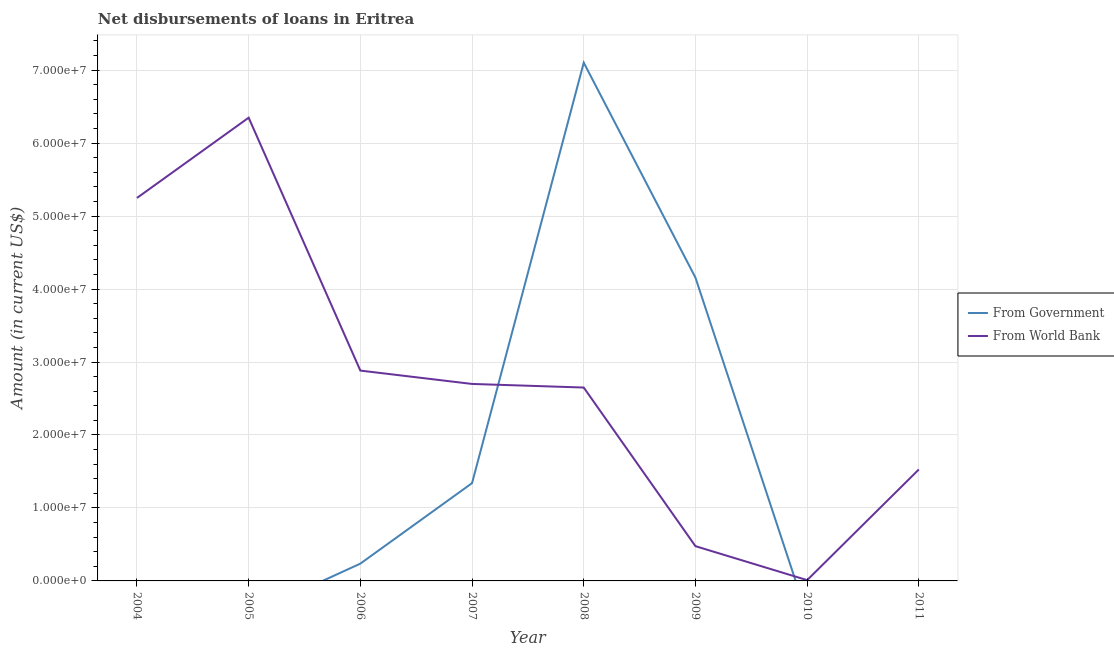Does the line corresponding to net disbursements of loan from government intersect with the line corresponding to net disbursements of loan from world bank?
Provide a short and direct response. Yes. Is the number of lines equal to the number of legend labels?
Provide a short and direct response. No. What is the net disbursements of loan from government in 2009?
Give a very brief answer. 4.16e+07. Across all years, what is the maximum net disbursements of loan from world bank?
Keep it short and to the point. 6.35e+07. Across all years, what is the minimum net disbursements of loan from world bank?
Give a very brief answer. 1.08e+05. In which year was the net disbursements of loan from world bank maximum?
Offer a terse response. 2005. What is the total net disbursements of loan from world bank in the graph?
Give a very brief answer. 2.18e+08. What is the difference between the net disbursements of loan from world bank in 2004 and that in 2005?
Keep it short and to the point. -1.10e+07. What is the difference between the net disbursements of loan from government in 2011 and the net disbursements of loan from world bank in 2005?
Offer a very short reply. -6.35e+07. What is the average net disbursements of loan from government per year?
Provide a succinct answer. 1.60e+07. In the year 2008, what is the difference between the net disbursements of loan from world bank and net disbursements of loan from government?
Offer a terse response. -4.45e+07. What is the ratio of the net disbursements of loan from world bank in 2005 to that in 2007?
Give a very brief answer. 2.35. Is the net disbursements of loan from government in 2006 less than that in 2009?
Ensure brevity in your answer.  Yes. What is the difference between the highest and the second highest net disbursements of loan from world bank?
Keep it short and to the point. 1.10e+07. What is the difference between the highest and the lowest net disbursements of loan from government?
Your answer should be very brief. 7.10e+07. Is the sum of the net disbursements of loan from world bank in 2005 and 2010 greater than the maximum net disbursements of loan from government across all years?
Make the answer very short. No. Does the net disbursements of loan from government monotonically increase over the years?
Provide a succinct answer. No. Is the net disbursements of loan from government strictly greater than the net disbursements of loan from world bank over the years?
Make the answer very short. No. Is the net disbursements of loan from government strictly less than the net disbursements of loan from world bank over the years?
Ensure brevity in your answer.  No. How many years are there in the graph?
Make the answer very short. 8. Are the values on the major ticks of Y-axis written in scientific E-notation?
Offer a terse response. Yes. Does the graph contain grids?
Make the answer very short. Yes. How are the legend labels stacked?
Offer a terse response. Vertical. What is the title of the graph?
Provide a succinct answer. Net disbursements of loans in Eritrea. What is the Amount (in current US$) of From Government in 2004?
Give a very brief answer. 0. What is the Amount (in current US$) of From World Bank in 2004?
Keep it short and to the point. 5.25e+07. What is the Amount (in current US$) of From World Bank in 2005?
Offer a very short reply. 6.35e+07. What is the Amount (in current US$) in From Government in 2006?
Ensure brevity in your answer.  2.37e+06. What is the Amount (in current US$) of From World Bank in 2006?
Provide a succinct answer. 2.88e+07. What is the Amount (in current US$) in From Government in 2007?
Keep it short and to the point. 1.34e+07. What is the Amount (in current US$) of From World Bank in 2007?
Your answer should be compact. 2.70e+07. What is the Amount (in current US$) of From Government in 2008?
Make the answer very short. 7.10e+07. What is the Amount (in current US$) in From World Bank in 2008?
Ensure brevity in your answer.  2.65e+07. What is the Amount (in current US$) of From Government in 2009?
Your response must be concise. 4.16e+07. What is the Amount (in current US$) in From World Bank in 2009?
Your answer should be compact. 4.76e+06. What is the Amount (in current US$) in From World Bank in 2010?
Your answer should be very brief. 1.08e+05. What is the Amount (in current US$) of From World Bank in 2011?
Give a very brief answer. 1.53e+07. Across all years, what is the maximum Amount (in current US$) of From Government?
Provide a short and direct response. 7.10e+07. Across all years, what is the maximum Amount (in current US$) in From World Bank?
Provide a short and direct response. 6.35e+07. Across all years, what is the minimum Amount (in current US$) of From Government?
Provide a short and direct response. 0. Across all years, what is the minimum Amount (in current US$) of From World Bank?
Keep it short and to the point. 1.08e+05. What is the total Amount (in current US$) in From Government in the graph?
Offer a terse response. 1.28e+08. What is the total Amount (in current US$) of From World Bank in the graph?
Offer a very short reply. 2.18e+08. What is the difference between the Amount (in current US$) of From World Bank in 2004 and that in 2005?
Offer a very short reply. -1.10e+07. What is the difference between the Amount (in current US$) of From World Bank in 2004 and that in 2006?
Offer a terse response. 2.37e+07. What is the difference between the Amount (in current US$) of From World Bank in 2004 and that in 2007?
Provide a succinct answer. 2.55e+07. What is the difference between the Amount (in current US$) of From World Bank in 2004 and that in 2008?
Offer a terse response. 2.60e+07. What is the difference between the Amount (in current US$) of From World Bank in 2004 and that in 2009?
Keep it short and to the point. 4.77e+07. What is the difference between the Amount (in current US$) of From World Bank in 2004 and that in 2010?
Your response must be concise. 5.24e+07. What is the difference between the Amount (in current US$) in From World Bank in 2004 and that in 2011?
Offer a terse response. 3.72e+07. What is the difference between the Amount (in current US$) in From World Bank in 2005 and that in 2006?
Your answer should be compact. 3.47e+07. What is the difference between the Amount (in current US$) in From World Bank in 2005 and that in 2007?
Your answer should be very brief. 3.65e+07. What is the difference between the Amount (in current US$) in From World Bank in 2005 and that in 2008?
Give a very brief answer. 3.70e+07. What is the difference between the Amount (in current US$) of From World Bank in 2005 and that in 2009?
Ensure brevity in your answer.  5.87e+07. What is the difference between the Amount (in current US$) of From World Bank in 2005 and that in 2010?
Your answer should be compact. 6.34e+07. What is the difference between the Amount (in current US$) in From World Bank in 2005 and that in 2011?
Provide a short and direct response. 4.82e+07. What is the difference between the Amount (in current US$) in From Government in 2006 and that in 2007?
Offer a terse response. -1.10e+07. What is the difference between the Amount (in current US$) in From World Bank in 2006 and that in 2007?
Make the answer very short. 1.83e+06. What is the difference between the Amount (in current US$) in From Government in 2006 and that in 2008?
Offer a very short reply. -6.87e+07. What is the difference between the Amount (in current US$) of From World Bank in 2006 and that in 2008?
Ensure brevity in your answer.  2.32e+06. What is the difference between the Amount (in current US$) in From Government in 2006 and that in 2009?
Offer a terse response. -3.92e+07. What is the difference between the Amount (in current US$) of From World Bank in 2006 and that in 2009?
Give a very brief answer. 2.41e+07. What is the difference between the Amount (in current US$) in From World Bank in 2006 and that in 2010?
Offer a very short reply. 2.87e+07. What is the difference between the Amount (in current US$) in From World Bank in 2006 and that in 2011?
Provide a succinct answer. 1.35e+07. What is the difference between the Amount (in current US$) in From Government in 2007 and that in 2008?
Give a very brief answer. -5.76e+07. What is the difference between the Amount (in current US$) of From World Bank in 2007 and that in 2008?
Make the answer very short. 4.93e+05. What is the difference between the Amount (in current US$) in From Government in 2007 and that in 2009?
Your response must be concise. -2.82e+07. What is the difference between the Amount (in current US$) in From World Bank in 2007 and that in 2009?
Provide a succinct answer. 2.22e+07. What is the difference between the Amount (in current US$) in From World Bank in 2007 and that in 2010?
Your answer should be very brief. 2.69e+07. What is the difference between the Amount (in current US$) in From World Bank in 2007 and that in 2011?
Make the answer very short. 1.17e+07. What is the difference between the Amount (in current US$) of From Government in 2008 and that in 2009?
Provide a short and direct response. 2.95e+07. What is the difference between the Amount (in current US$) of From World Bank in 2008 and that in 2009?
Provide a short and direct response. 2.17e+07. What is the difference between the Amount (in current US$) of From World Bank in 2008 and that in 2010?
Make the answer very short. 2.64e+07. What is the difference between the Amount (in current US$) of From World Bank in 2008 and that in 2011?
Ensure brevity in your answer.  1.12e+07. What is the difference between the Amount (in current US$) in From World Bank in 2009 and that in 2010?
Offer a terse response. 4.66e+06. What is the difference between the Amount (in current US$) in From World Bank in 2009 and that in 2011?
Provide a succinct answer. -1.05e+07. What is the difference between the Amount (in current US$) of From World Bank in 2010 and that in 2011?
Offer a terse response. -1.52e+07. What is the difference between the Amount (in current US$) in From Government in 2006 and the Amount (in current US$) in From World Bank in 2007?
Ensure brevity in your answer.  -2.46e+07. What is the difference between the Amount (in current US$) in From Government in 2006 and the Amount (in current US$) in From World Bank in 2008?
Provide a short and direct response. -2.41e+07. What is the difference between the Amount (in current US$) in From Government in 2006 and the Amount (in current US$) in From World Bank in 2009?
Give a very brief answer. -2.39e+06. What is the difference between the Amount (in current US$) in From Government in 2006 and the Amount (in current US$) in From World Bank in 2010?
Ensure brevity in your answer.  2.26e+06. What is the difference between the Amount (in current US$) in From Government in 2006 and the Amount (in current US$) in From World Bank in 2011?
Ensure brevity in your answer.  -1.29e+07. What is the difference between the Amount (in current US$) of From Government in 2007 and the Amount (in current US$) of From World Bank in 2008?
Make the answer very short. -1.31e+07. What is the difference between the Amount (in current US$) in From Government in 2007 and the Amount (in current US$) in From World Bank in 2009?
Make the answer very short. 8.64e+06. What is the difference between the Amount (in current US$) of From Government in 2007 and the Amount (in current US$) of From World Bank in 2010?
Make the answer very short. 1.33e+07. What is the difference between the Amount (in current US$) in From Government in 2007 and the Amount (in current US$) in From World Bank in 2011?
Your response must be concise. -1.88e+06. What is the difference between the Amount (in current US$) of From Government in 2008 and the Amount (in current US$) of From World Bank in 2009?
Give a very brief answer. 6.63e+07. What is the difference between the Amount (in current US$) of From Government in 2008 and the Amount (in current US$) of From World Bank in 2010?
Your answer should be very brief. 7.09e+07. What is the difference between the Amount (in current US$) in From Government in 2008 and the Amount (in current US$) in From World Bank in 2011?
Provide a short and direct response. 5.58e+07. What is the difference between the Amount (in current US$) in From Government in 2009 and the Amount (in current US$) in From World Bank in 2010?
Keep it short and to the point. 4.15e+07. What is the difference between the Amount (in current US$) in From Government in 2009 and the Amount (in current US$) in From World Bank in 2011?
Make the answer very short. 2.63e+07. What is the average Amount (in current US$) in From Government per year?
Your answer should be very brief. 1.60e+07. What is the average Amount (in current US$) in From World Bank per year?
Your answer should be very brief. 2.73e+07. In the year 2006, what is the difference between the Amount (in current US$) of From Government and Amount (in current US$) of From World Bank?
Your response must be concise. -2.65e+07. In the year 2007, what is the difference between the Amount (in current US$) in From Government and Amount (in current US$) in From World Bank?
Provide a short and direct response. -1.36e+07. In the year 2008, what is the difference between the Amount (in current US$) in From Government and Amount (in current US$) in From World Bank?
Provide a short and direct response. 4.45e+07. In the year 2009, what is the difference between the Amount (in current US$) in From Government and Amount (in current US$) in From World Bank?
Ensure brevity in your answer.  3.68e+07. What is the ratio of the Amount (in current US$) in From World Bank in 2004 to that in 2005?
Your response must be concise. 0.83. What is the ratio of the Amount (in current US$) of From World Bank in 2004 to that in 2006?
Offer a terse response. 1.82. What is the ratio of the Amount (in current US$) in From World Bank in 2004 to that in 2007?
Provide a succinct answer. 1.94. What is the ratio of the Amount (in current US$) of From World Bank in 2004 to that in 2008?
Offer a terse response. 1.98. What is the ratio of the Amount (in current US$) of From World Bank in 2004 to that in 2009?
Make the answer very short. 11.02. What is the ratio of the Amount (in current US$) in From World Bank in 2004 to that in 2010?
Your response must be concise. 485.98. What is the ratio of the Amount (in current US$) in From World Bank in 2004 to that in 2011?
Your answer should be compact. 3.44. What is the ratio of the Amount (in current US$) of From World Bank in 2005 to that in 2006?
Offer a terse response. 2.2. What is the ratio of the Amount (in current US$) in From World Bank in 2005 to that in 2007?
Your response must be concise. 2.35. What is the ratio of the Amount (in current US$) of From World Bank in 2005 to that in 2008?
Your response must be concise. 2.4. What is the ratio of the Amount (in current US$) of From World Bank in 2005 to that in 2009?
Your response must be concise. 13.33. What is the ratio of the Amount (in current US$) of From World Bank in 2005 to that in 2010?
Ensure brevity in your answer.  587.83. What is the ratio of the Amount (in current US$) in From World Bank in 2005 to that in 2011?
Keep it short and to the point. 4.16. What is the ratio of the Amount (in current US$) in From Government in 2006 to that in 2007?
Make the answer very short. 0.18. What is the ratio of the Amount (in current US$) in From World Bank in 2006 to that in 2007?
Your response must be concise. 1.07. What is the ratio of the Amount (in current US$) in From Government in 2006 to that in 2008?
Offer a terse response. 0.03. What is the ratio of the Amount (in current US$) in From World Bank in 2006 to that in 2008?
Provide a succinct answer. 1.09. What is the ratio of the Amount (in current US$) in From Government in 2006 to that in 2009?
Offer a very short reply. 0.06. What is the ratio of the Amount (in current US$) in From World Bank in 2006 to that in 2009?
Provide a succinct answer. 6.05. What is the ratio of the Amount (in current US$) in From World Bank in 2006 to that in 2010?
Ensure brevity in your answer.  266.91. What is the ratio of the Amount (in current US$) in From World Bank in 2006 to that in 2011?
Offer a terse response. 1.89. What is the ratio of the Amount (in current US$) in From Government in 2007 to that in 2008?
Your answer should be compact. 0.19. What is the ratio of the Amount (in current US$) of From World Bank in 2007 to that in 2008?
Provide a succinct answer. 1.02. What is the ratio of the Amount (in current US$) of From Government in 2007 to that in 2009?
Make the answer very short. 0.32. What is the ratio of the Amount (in current US$) of From World Bank in 2007 to that in 2009?
Ensure brevity in your answer.  5.67. What is the ratio of the Amount (in current US$) of From World Bank in 2007 to that in 2010?
Give a very brief answer. 249.96. What is the ratio of the Amount (in current US$) in From World Bank in 2007 to that in 2011?
Your answer should be very brief. 1.77. What is the ratio of the Amount (in current US$) in From Government in 2008 to that in 2009?
Keep it short and to the point. 1.71. What is the ratio of the Amount (in current US$) of From World Bank in 2008 to that in 2009?
Your answer should be compact. 5.56. What is the ratio of the Amount (in current US$) of From World Bank in 2008 to that in 2010?
Provide a short and direct response. 245.4. What is the ratio of the Amount (in current US$) in From World Bank in 2008 to that in 2011?
Offer a terse response. 1.73. What is the ratio of the Amount (in current US$) in From World Bank in 2009 to that in 2010?
Keep it short and to the point. 44.1. What is the ratio of the Amount (in current US$) in From World Bank in 2009 to that in 2011?
Give a very brief answer. 0.31. What is the ratio of the Amount (in current US$) in From World Bank in 2010 to that in 2011?
Offer a very short reply. 0.01. What is the difference between the highest and the second highest Amount (in current US$) of From Government?
Ensure brevity in your answer.  2.95e+07. What is the difference between the highest and the second highest Amount (in current US$) of From World Bank?
Your response must be concise. 1.10e+07. What is the difference between the highest and the lowest Amount (in current US$) in From Government?
Provide a succinct answer. 7.10e+07. What is the difference between the highest and the lowest Amount (in current US$) in From World Bank?
Make the answer very short. 6.34e+07. 